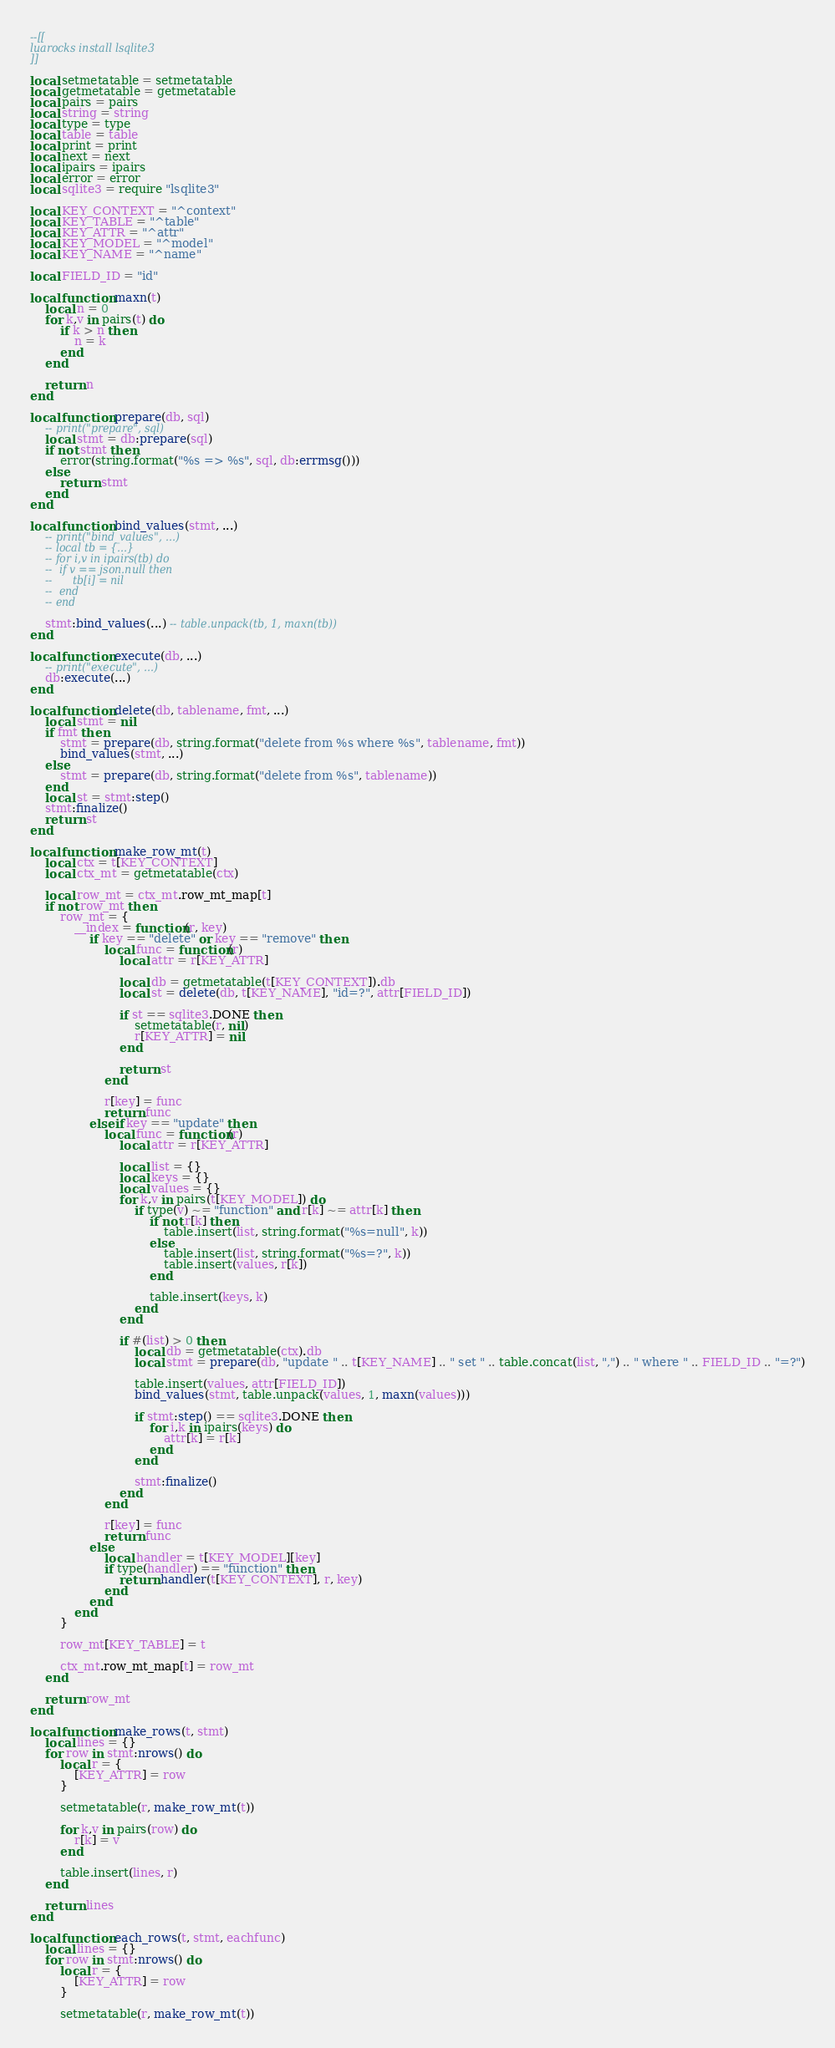<code> <loc_0><loc_0><loc_500><loc_500><_Lua_>--[[
luarocks install lsqlite3
]]

local setmetatable = setmetatable
local getmetatable = getmetatable
local pairs = pairs
local string = string
local type = type
local table = table
local print = print
local next = next
local ipairs = ipairs
local error = error
local sqlite3 = require "lsqlite3"

local KEY_CONTEXT = "^context"
local KEY_TABLE = "^table"
local KEY_ATTR = "^attr"
local KEY_MODEL = "^model"
local KEY_NAME = "^name"

local FIELD_ID = "id"

local function maxn(t)
    local n = 0
    for k,v in pairs(t) do
        if k > n then
            n = k
        end
    end

    return n
end

local function prepare(db, sql)
	-- print("prepare", sql)
	local stmt = db:prepare(sql)
	if not stmt then
		error(string.format("%s => %s", sql, db:errmsg()))
	else
		return stmt
	end
end

local function bind_values(stmt, ...)
	-- print("bind_values", ...)
	-- local tb = {...}
	-- for i,v in ipairs(tb) do
	-- 	if v == json.null then
	-- 		tb[i] = nil
	-- 	end
	-- end

	stmt:bind_values(...) -- table.unpack(tb, 1, maxn(tb))
end

local function execute(db, ...)
	-- print("execute", ...)
	db:execute(...)
end

local function delete(db, tablename, fmt, ...)
	local stmt = nil
	if fmt then
		stmt = prepare(db, string.format("delete from %s where %s", tablename, fmt))
		bind_values(stmt, ...)
	else
		stmt = prepare(db, string.format("delete from %s", tablename))
	end
	local st = stmt:step()
	stmt:finalize()
	return st
end

local function make_row_mt(t)
	local ctx = t[KEY_CONTEXT]
	local ctx_mt = getmetatable(ctx)

	local row_mt = ctx_mt.row_mt_map[t]
	if not row_mt then
		row_mt = {
			__index = function(r, key)
				if key == "delete" or key == "remove" then
					local func = function(r)
						local attr = r[KEY_ATTR]

						local db = getmetatable(t[KEY_CONTEXT]).db
						local st = delete(db, t[KEY_NAME], "id=?", attr[FIELD_ID])

						if st == sqlite3.DONE then
							setmetatable(r, nil)
							r[KEY_ATTR] = nil
						end

						return st
					end

					r[key] = func
					return func
				elseif key == "update" then
					local func = function(r)
						local attr = r[KEY_ATTR]

						local list = {}
						local keys = {}
						local values = {}
						for k,v in pairs(t[KEY_MODEL]) do
							if type(v) ~= "function" and r[k] ~= attr[k] then
								if not r[k] then
									table.insert(list, string.format("%s=null", k))
								else
									table.insert(list, string.format("%s=?", k))
									table.insert(values, r[k])
								end

								table.insert(keys, k)
							end
						end

						if #(list) > 0 then
							local db = getmetatable(ctx).db
							local stmt = prepare(db, "update " .. t[KEY_NAME] .. " set " .. table.concat(list, ",") .. " where " .. FIELD_ID .. "=?")

							table.insert(values, attr[FIELD_ID])
							bind_values(stmt, table.unpack(values, 1, maxn(values)))

							if stmt:step() == sqlite3.DONE then
								for i,k in ipairs(keys) do
									attr[k] = r[k]
								end
							end

							stmt:finalize()
						end
					end

					r[key] = func
					return func
				else
					local handler = t[KEY_MODEL][key]
					if type(handler) == "function" then
						return handler(t[KEY_CONTEXT], r, key)
					end
				end
			end
		}

		row_mt[KEY_TABLE] = t

		ctx_mt.row_mt_map[t] = row_mt
	end

	return row_mt
end

local function make_rows(t, stmt)
	local lines = {}
	for row in stmt:nrows() do
		local r = {
			[KEY_ATTR] = row
		}

		setmetatable(r, make_row_mt(t))

		for k,v in pairs(row) do
			r[k] = v
		end

		table.insert(lines, r)
	end

	return lines
end

local function each_rows(t, stmt, eachfunc)
	local lines = {}
	for row in stmt:nrows() do
		local r = {
			[KEY_ATTR] = row
		}

		setmetatable(r, make_row_mt(t))
</code> 